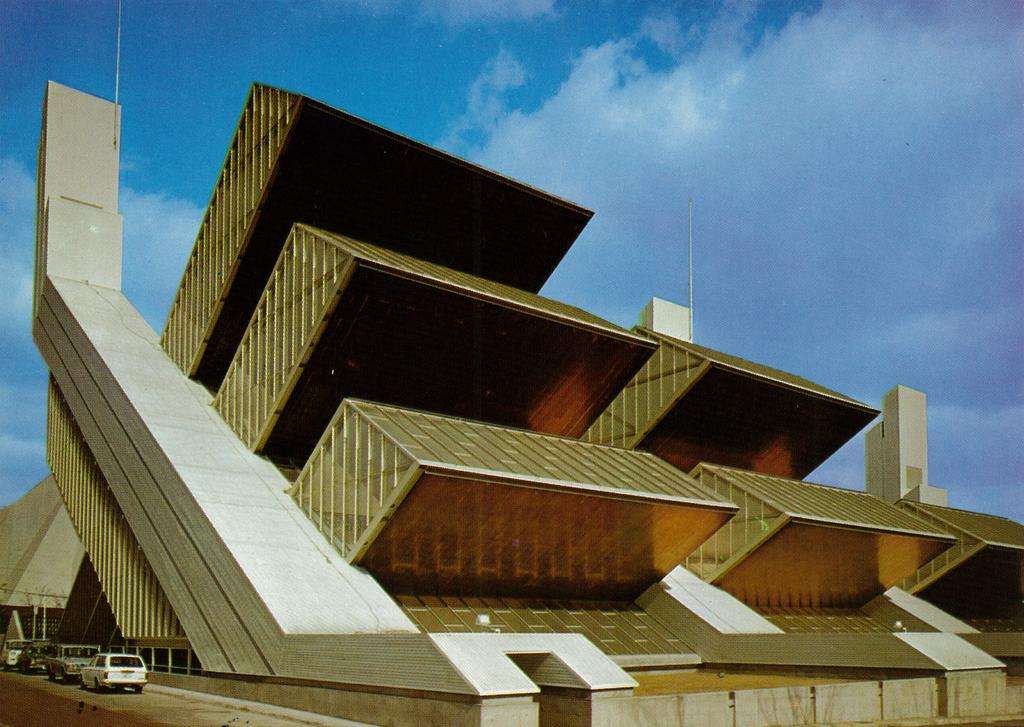What type of structure is present in the image? There is a building in the image. What else can be seen in the bottom left of the image? There are vehicles visible in the bottom left of the image. What is visible at the top of the image? The sky is visible at the top of the image. What type of iron can be seen in the image? There is no iron present in the image. What color is the cream in the image? There is no cream present in the image. 